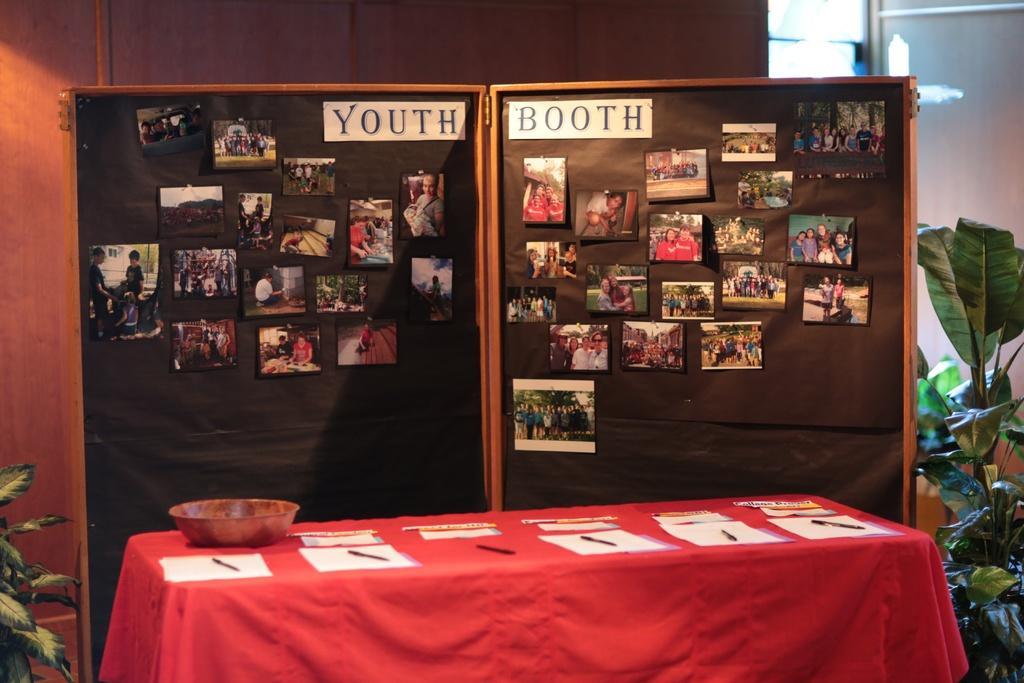Can you describe this image briefly? In this picture I can observe photographs on the black color board in the middle of the picture. In the bottom of the picture I can observe a table. On either sides of the picture I can observe plants. 